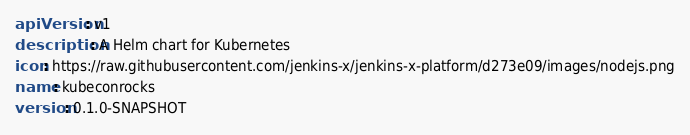Convert code to text. <code><loc_0><loc_0><loc_500><loc_500><_YAML_>apiVersion: v1
description: A Helm chart for Kubernetes
icon: https://raw.githubusercontent.com/jenkins-x/jenkins-x-platform/d273e09/images/nodejs.png
name: kubeconrocks
version: 0.1.0-SNAPSHOT
</code> 